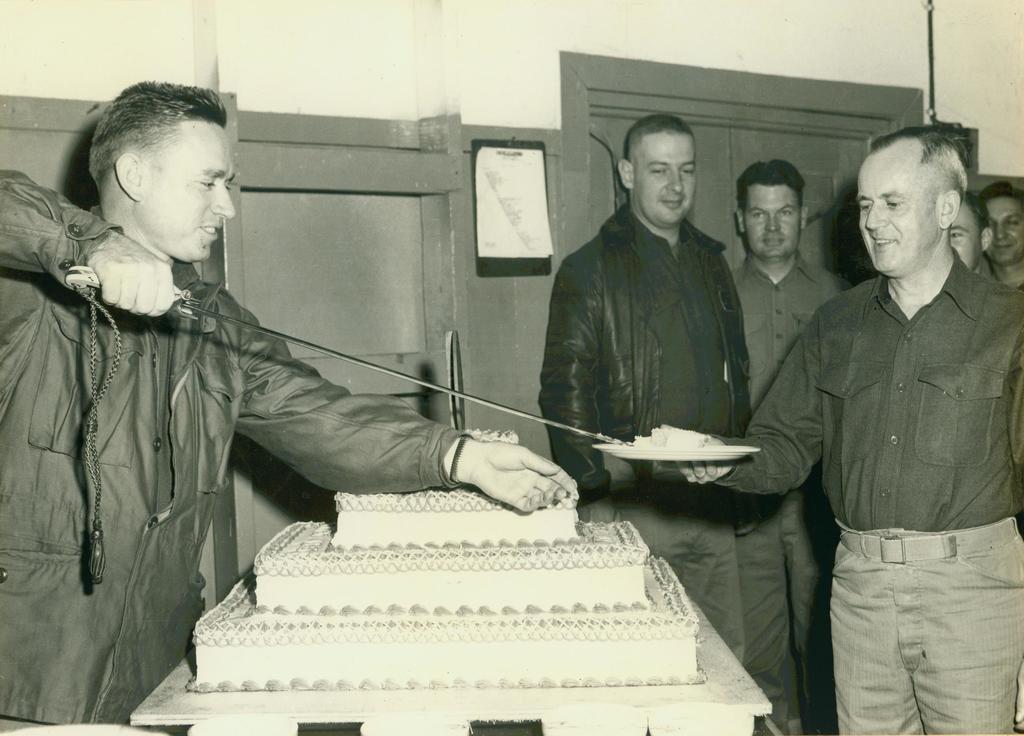Can you describe this image briefly? In this image we can see this person wearing jacket is holding a cake lifter, here we can cake kept on the table and this person is holding a plate and these people standing here. In the background, we can see the wall and the door. 